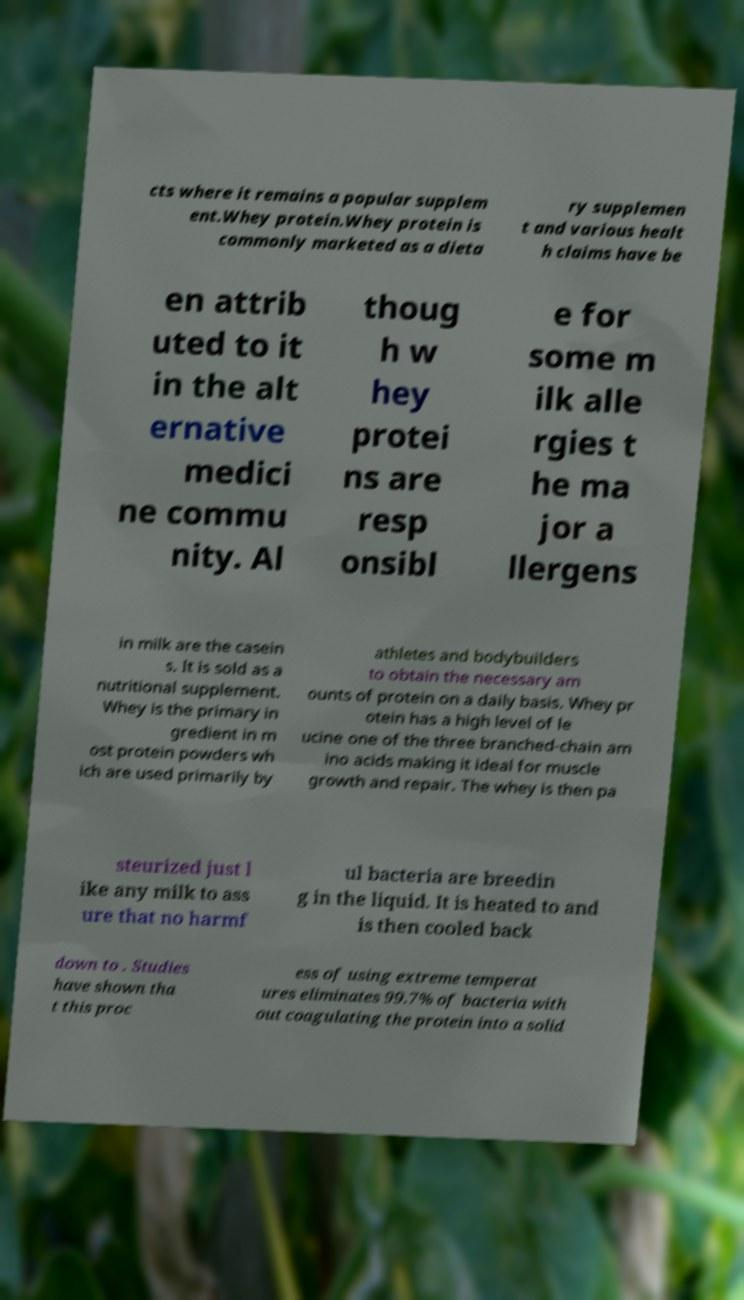Could you assist in decoding the text presented in this image and type it out clearly? cts where it remains a popular supplem ent.Whey protein.Whey protein is commonly marketed as a dieta ry supplemen t and various healt h claims have be en attrib uted to it in the alt ernative medici ne commu nity. Al thoug h w hey protei ns are resp onsibl e for some m ilk alle rgies t he ma jor a llergens in milk are the casein s. It is sold as a nutritional supplement. Whey is the primary in gredient in m ost protein powders wh ich are used primarily by athletes and bodybuilders to obtain the necessary am ounts of protein on a daily basis. Whey pr otein has a high level of le ucine one of the three branched-chain am ino acids making it ideal for muscle growth and repair. The whey is then pa steurized just l ike any milk to ass ure that no harmf ul bacteria are breedin g in the liquid. It is heated to and is then cooled back down to . Studies have shown tha t this proc ess of using extreme temperat ures eliminates 99.7% of bacteria with out coagulating the protein into a solid 